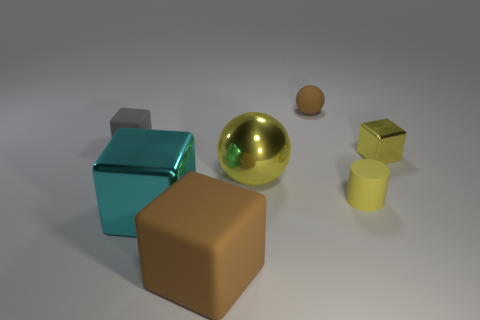There is a object on the right side of the tiny cylinder; does it have the same color as the big sphere?
Your answer should be very brief. Yes. How many objects are either big metal objects that are to the right of the big brown matte block or tiny blocks on the right side of the gray object?
Offer a very short reply. 2. What number of brown things are both in front of the brown sphere and behind the yellow rubber cylinder?
Provide a succinct answer. 0. Do the large brown object and the yellow block have the same material?
Make the answer very short. No. What shape is the big shiny thing to the left of the brown matte thing in front of the brown thing right of the big brown cube?
Provide a succinct answer. Cube. There is a cube that is behind the big yellow object and to the right of the cyan metallic block; what is it made of?
Keep it short and to the point. Metal. The small block that is left of the ball behind the small yellow object behind the big yellow object is what color?
Provide a succinct answer. Gray. How many purple things are large rubber things or metallic things?
Make the answer very short. 0. How many other things are there of the same size as the yellow matte cylinder?
Offer a very short reply. 3. What number of shiny cubes are there?
Offer a terse response. 2. 